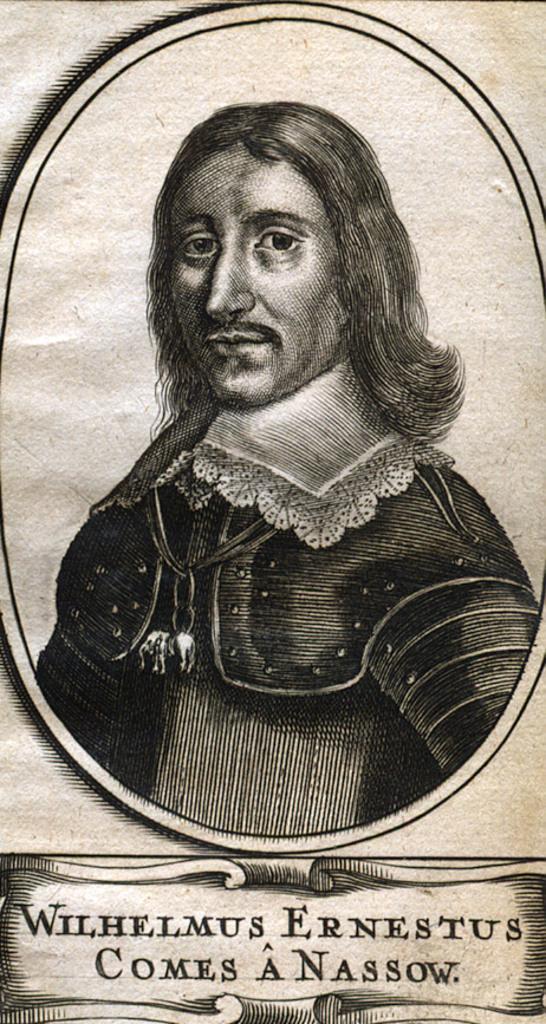Please provide a concise description of this image. In the foreground of this image, there is a man and some text at the bottom. 